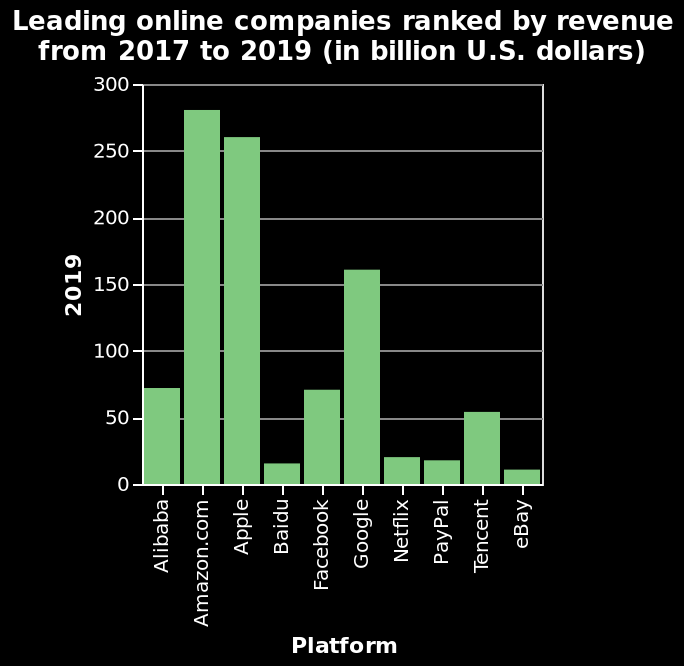<image>
please describe the details of the chart Here a is a bar plot titled Leading online companies ranked by revenue from 2017 to 2019 (in billion U.S. dollars). On the y-axis, 2019 is plotted with a linear scale of range 0 to 300. Platform is defined using a categorical scale starting at Alibaba and ending at eBay along the x-axis. What companies had the leading revenues in 2019? Amazon and Apple. What is the title of the bar plot?  The title of the bar plot is "Leading online companies ranked by revenue from 2017 to 2019 (in billion U.S. dollars)." Which company closely followed Amazon in terms of revenues in 2019? Apple. 